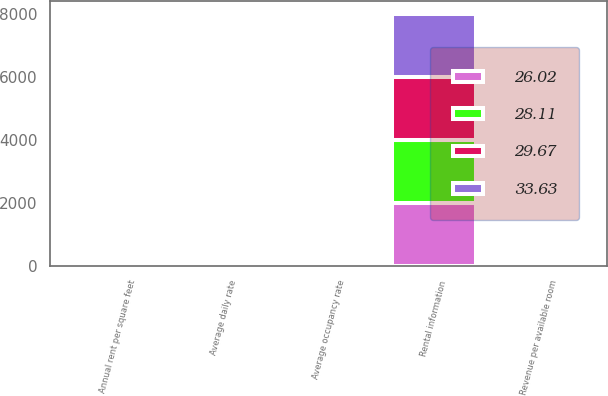Convert chart to OTSL. <chart><loc_0><loc_0><loc_500><loc_500><stacked_bar_chart><ecel><fcel>Rental information<fcel>Average occupancy rate<fcel>Average daily rate<fcel>Revenue per available room<fcel>Annual rent per square feet<nl><fcel>28.11<fcel>2007<fcel>84.4<fcel>154.78<fcel>130.7<fcel>22.23<nl><fcel>33.63<fcel>2006<fcel>82.1<fcel>133.33<fcel>109.53<fcel>16.42<nl><fcel>26.02<fcel>2005<fcel>83.7<fcel>115.74<fcel>96.85<fcel>10.7<nl><fcel>29.67<fcel>2004<fcel>78.9<fcel>97.36<fcel>77.56<fcel>10.04<nl></chart> 